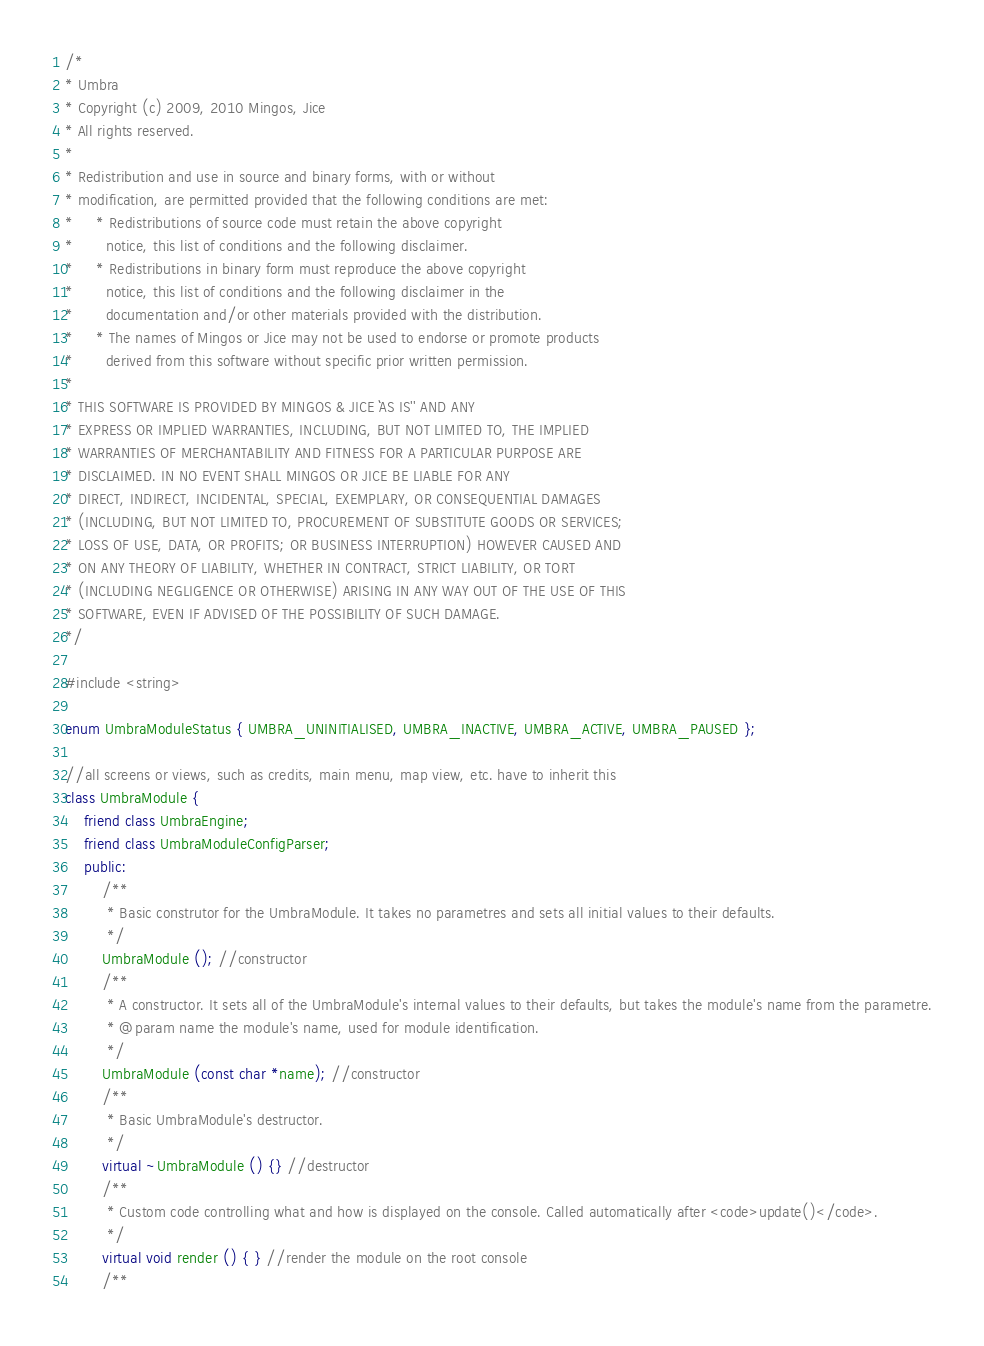<code> <loc_0><loc_0><loc_500><loc_500><_C++_>/*
* Umbra
* Copyright (c) 2009, 2010 Mingos, Jice
* All rights reserved.
*
* Redistribution and use in source and binary forms, with or without
* modification, are permitted provided that the following conditions are met:
*     * Redistributions of source code must retain the above copyright
*       notice, this list of conditions and the following disclaimer.
*     * Redistributions in binary form must reproduce the above copyright
*       notice, this list of conditions and the following disclaimer in the
*       documentation and/or other materials provided with the distribution.
*     * The names of Mingos or Jice may not be used to endorse or promote products
*       derived from this software without specific prior written permission.
*
* THIS SOFTWARE IS PROVIDED BY MINGOS & JICE ``AS IS'' AND ANY
* EXPRESS OR IMPLIED WARRANTIES, INCLUDING, BUT NOT LIMITED TO, THE IMPLIED
* WARRANTIES OF MERCHANTABILITY AND FITNESS FOR A PARTICULAR PURPOSE ARE
* DISCLAIMED. IN NO EVENT SHALL MINGOS OR JICE BE LIABLE FOR ANY
* DIRECT, INDIRECT, INCIDENTAL, SPECIAL, EXEMPLARY, OR CONSEQUENTIAL DAMAGES
* (INCLUDING, BUT NOT LIMITED TO, PROCUREMENT OF SUBSTITUTE GOODS OR SERVICES;
* LOSS OF USE, DATA, OR PROFITS; OR BUSINESS INTERRUPTION) HOWEVER CAUSED AND
* ON ANY THEORY OF LIABILITY, WHETHER IN CONTRACT, STRICT LIABILITY, OR TORT
* (INCLUDING NEGLIGENCE OR OTHERWISE) ARISING IN ANY WAY OUT OF THE USE OF THIS
* SOFTWARE, EVEN IF ADVISED OF THE POSSIBILITY OF SUCH DAMAGE.
*/

#include <string>

enum UmbraModuleStatus { UMBRA_UNINITIALISED, UMBRA_INACTIVE, UMBRA_ACTIVE, UMBRA_PAUSED };

//all screens or views, such as credits, main menu, map view, etc. have to inherit this
class UmbraModule {
	friend class UmbraEngine;
	friend class UmbraModuleConfigParser;
	public:
		/**
		 * Basic construtor for the UmbraModule. It takes no parametres and sets all initial values to their defaults.
         */
		UmbraModule (); //constructor
		/**
		 * A constructor. It sets all of the UmbraModule's internal values to their defaults, but takes the module's name from the parametre.
         * @param name the module's name, used for module identification.
         */
		UmbraModule (const char *name); //constructor
		/**
		 * Basic UmbraModule's destructor.
         */
		virtual ~UmbraModule () {} //destructor
		/**
		 * Custom code controlling what and how is displayed on the console. Called automatically after <code>update()</code>.
		 */
		virtual void render () { } //render the module on the root console
		/**</code> 